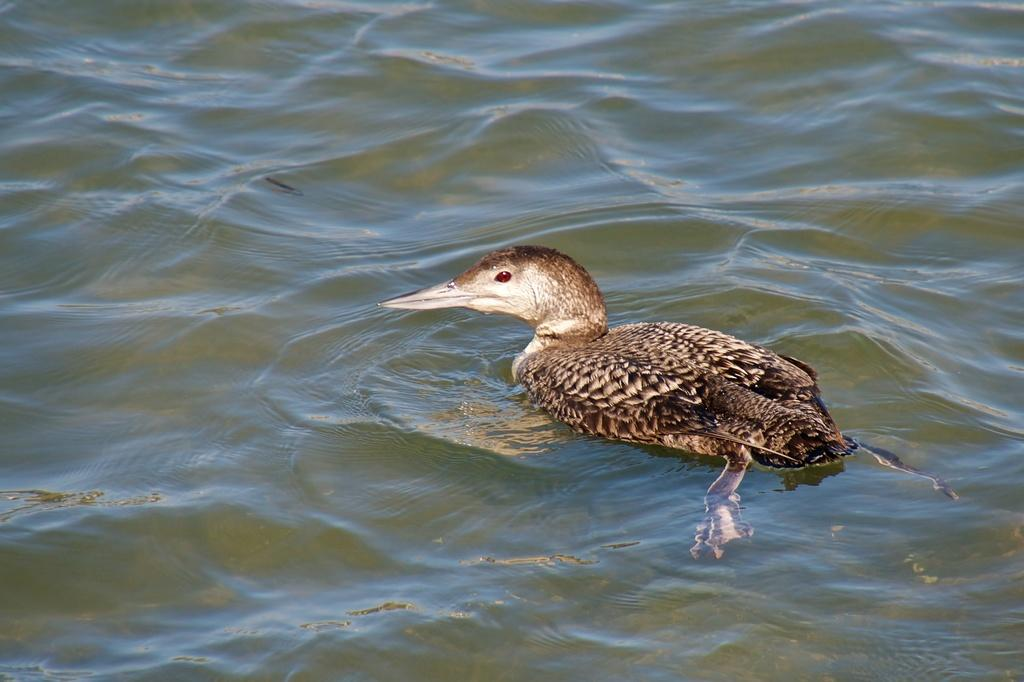What animal is present in the image? There is a duck in the image. Where is the duck located? The duck is on the water. Is there a crown visible on the duck's head in the image? No, there is no crown present on the duck's head in the image. 